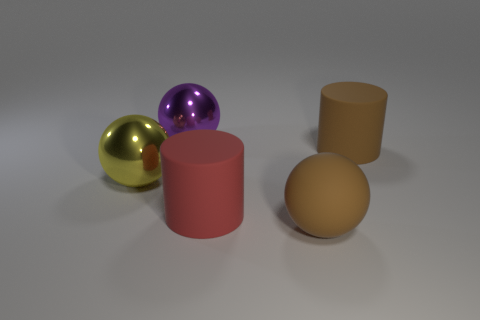Add 4 big gray cubes. How many objects exist? 9 Subtract all cylinders. How many objects are left? 3 Subtract all spheres. Subtract all purple shiny objects. How many objects are left? 1 Add 2 big brown spheres. How many big brown spheres are left? 3 Add 5 big brown matte objects. How many big brown matte objects exist? 7 Subtract 0 cyan cylinders. How many objects are left? 5 